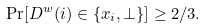Convert formula to latex. <formula><loc_0><loc_0><loc_500><loc_500>\Pr [ D ^ { w } ( i ) \in \{ x _ { i } , \bot \} ] \geq 2 / 3 .</formula> 